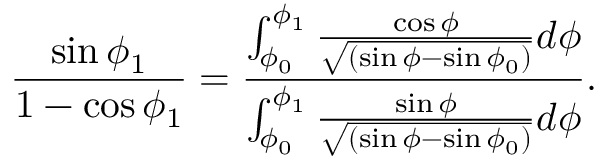<formula> <loc_0><loc_0><loc_500><loc_500>\frac { \sin \phi _ { 1 } } { 1 - \cos \phi _ { 1 } } = \frac { \int _ { \phi _ { 0 } } ^ { \phi _ { 1 } } \frac { \cos \phi } { \sqrt { ( \sin \phi - \sin \phi _ { 0 } ) } } d \phi } { \int _ { \phi _ { 0 } } ^ { \phi _ { 1 } } \frac { \sin \phi } { \sqrt { ( \sin \phi - \sin \phi _ { 0 } ) } } d \phi } .</formula> 